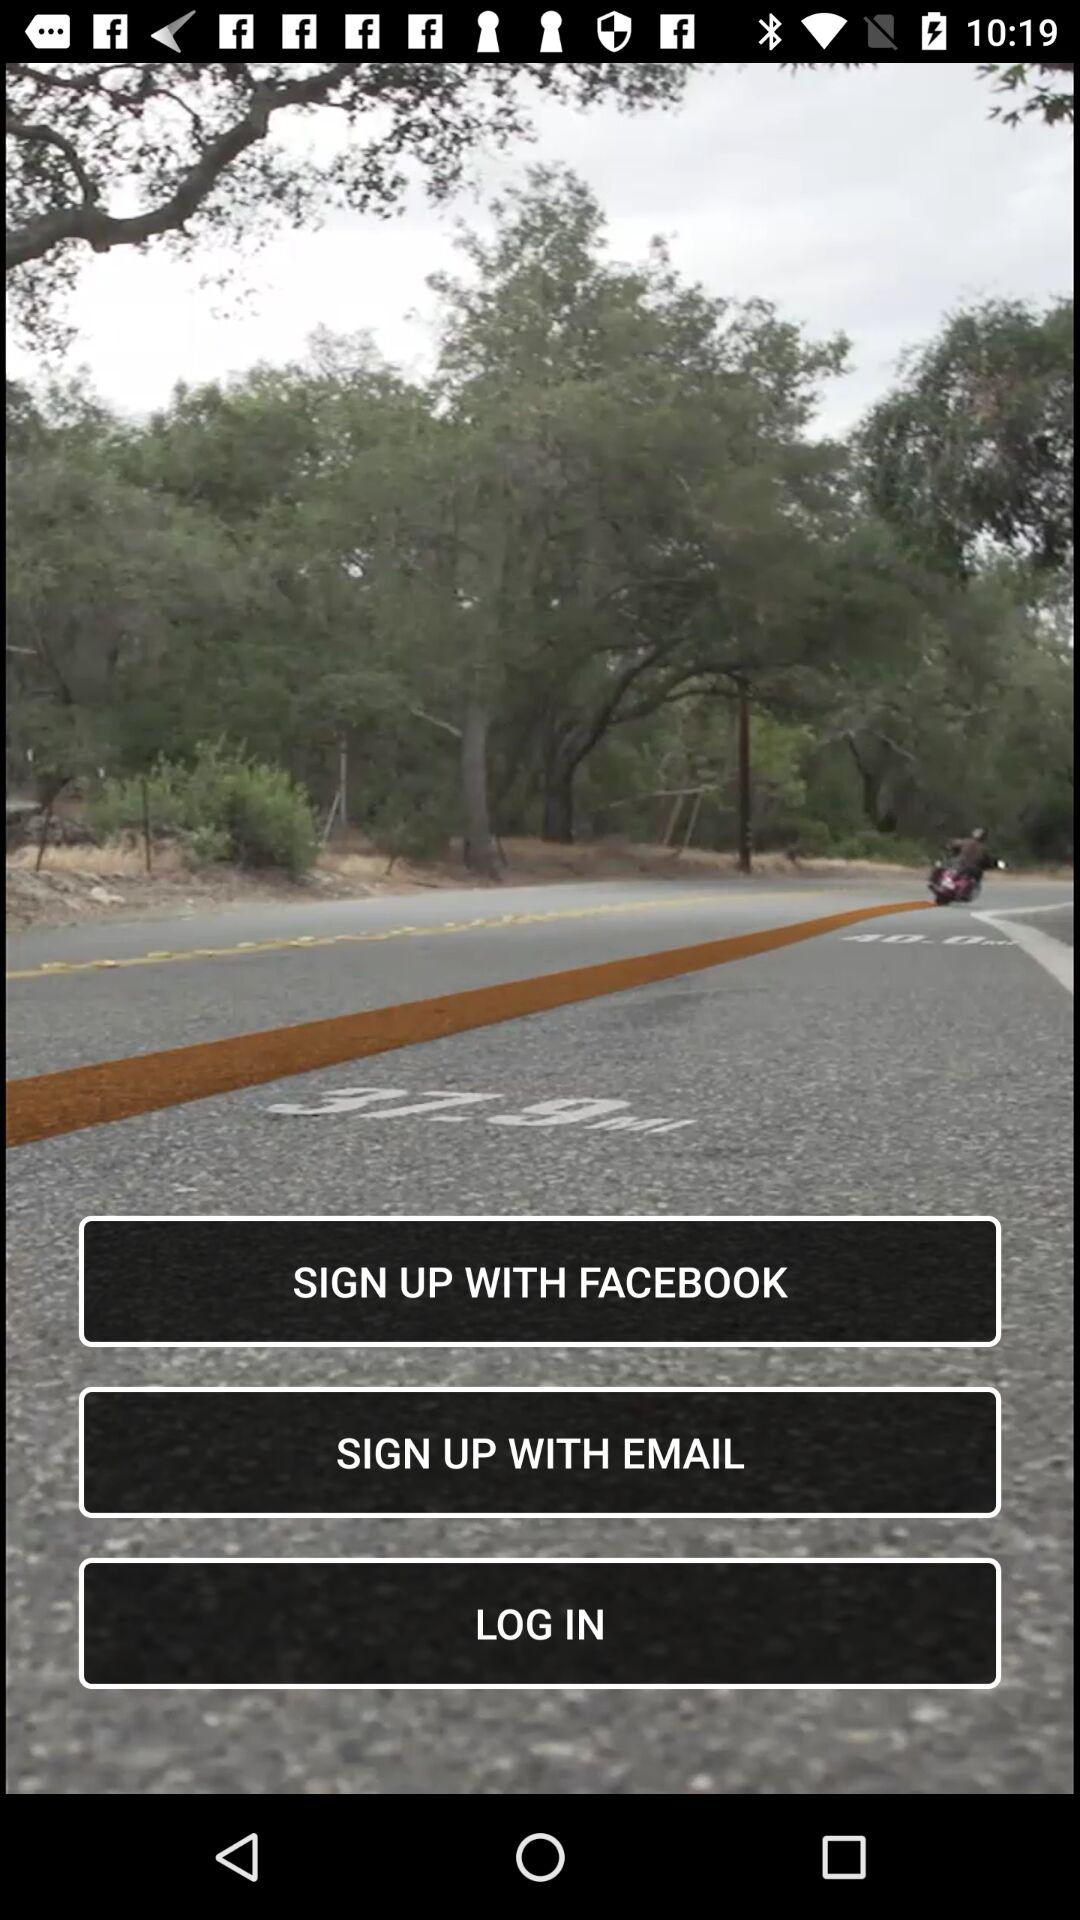Through which accounts can sign-up be done? Sign-up can be done through "FACEBOOK" and "EMAIL" accounts. 